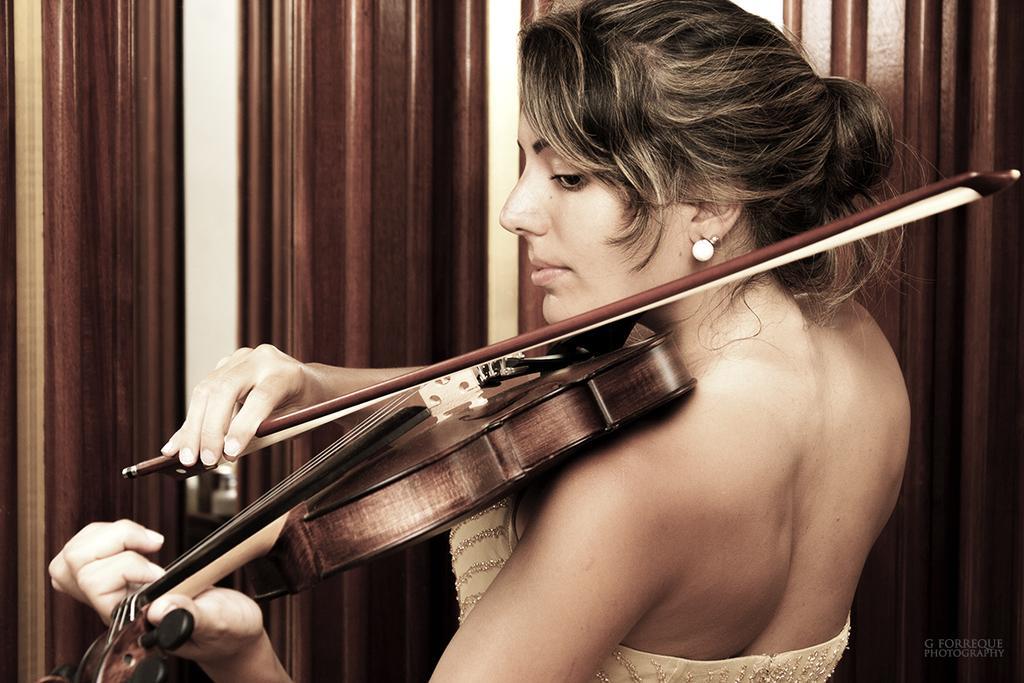Please provide a concise description of this image. This is the woman standing and playing violin. She wore a dress and ear studs. At background this looks like a wooden texture wall. 